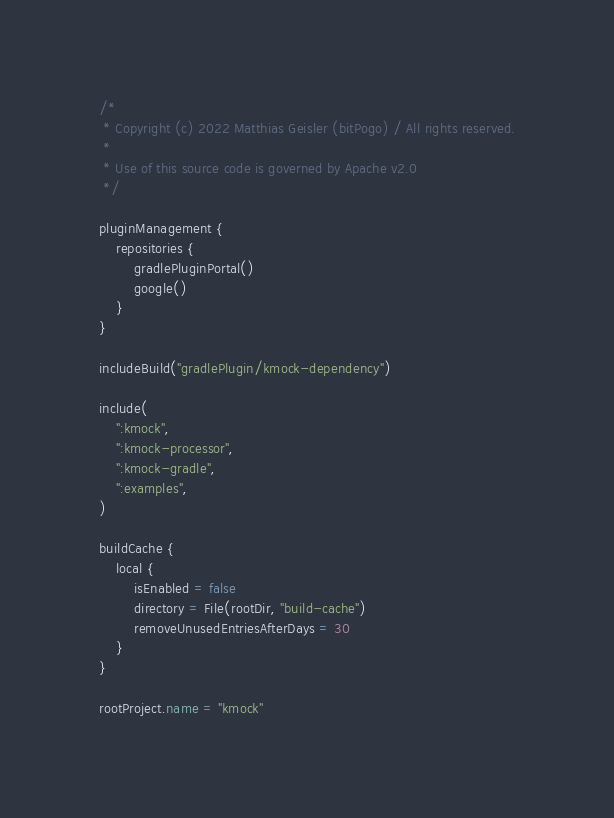Convert code to text. <code><loc_0><loc_0><loc_500><loc_500><_Kotlin_>/*
 * Copyright (c) 2022 Matthias Geisler (bitPogo) / All rights reserved.
 *
 * Use of this source code is governed by Apache v2.0
 */

pluginManagement {
    repositories {
        gradlePluginPortal()
        google()
    }
}

includeBuild("gradlePlugin/kmock-dependency")

include(
    ":kmock",
    ":kmock-processor",
    ":kmock-gradle",
    ":examples",
)

buildCache {
    local {
        isEnabled = false
        directory = File(rootDir, "build-cache")
        removeUnusedEntriesAfterDays = 30
    }
}

rootProject.name = "kmock"
</code> 